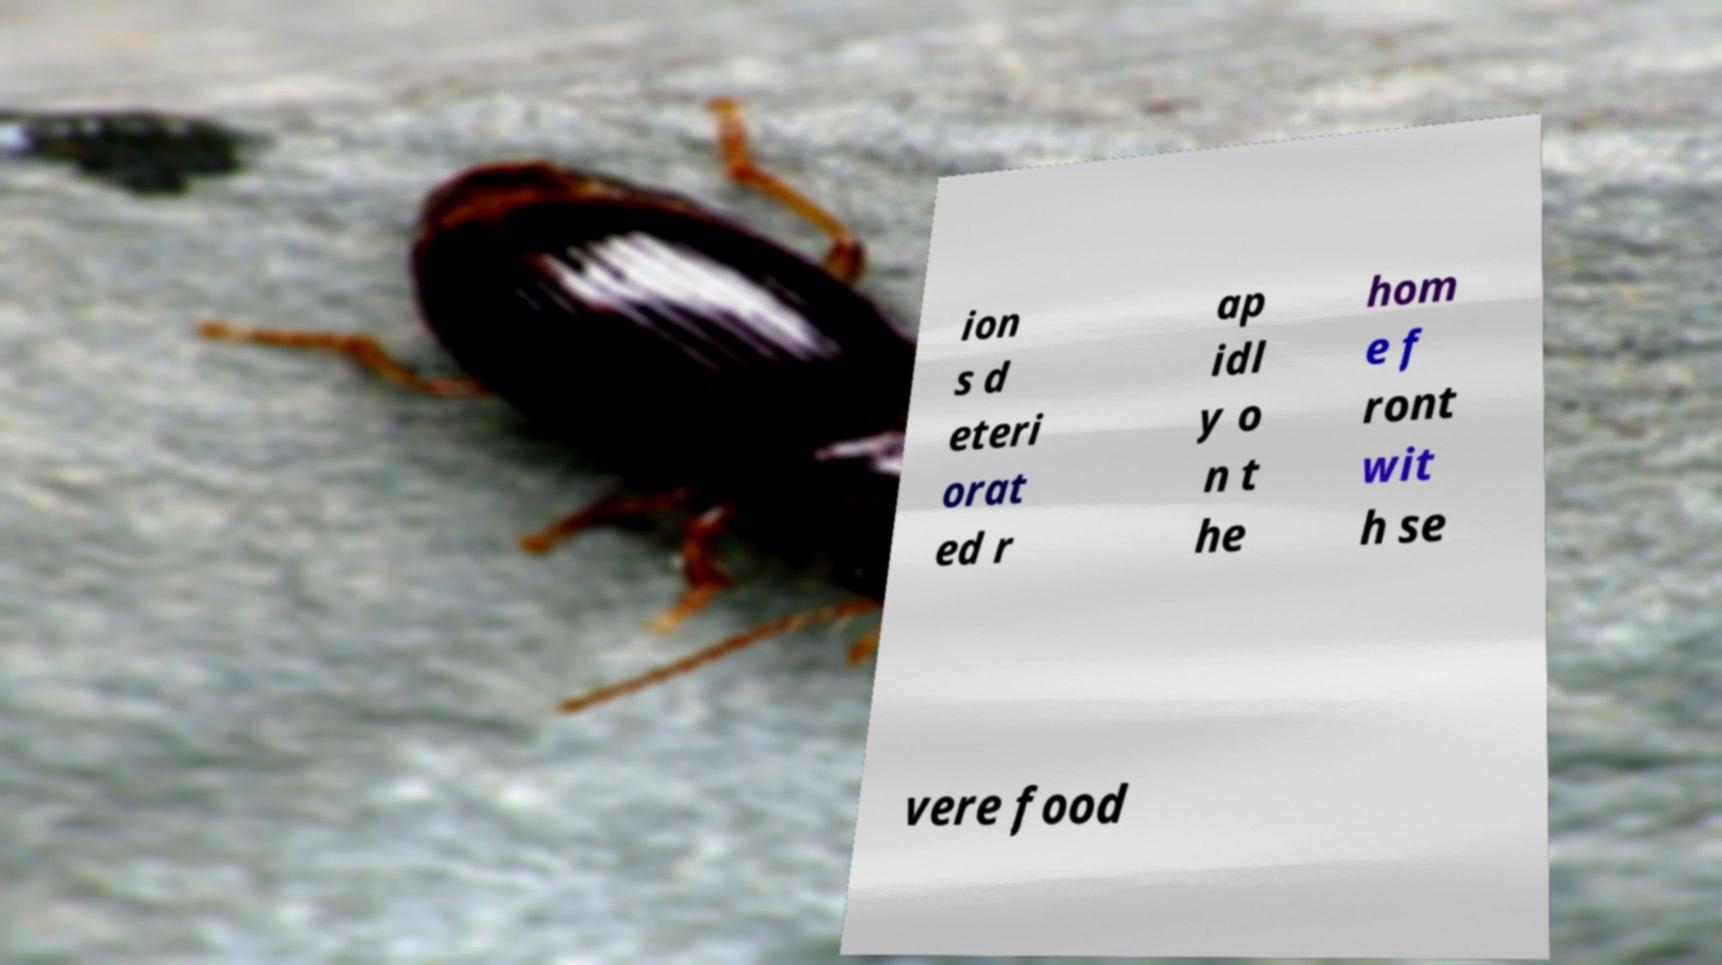Could you assist in decoding the text presented in this image and type it out clearly? ion s d eteri orat ed r ap idl y o n t he hom e f ront wit h se vere food 